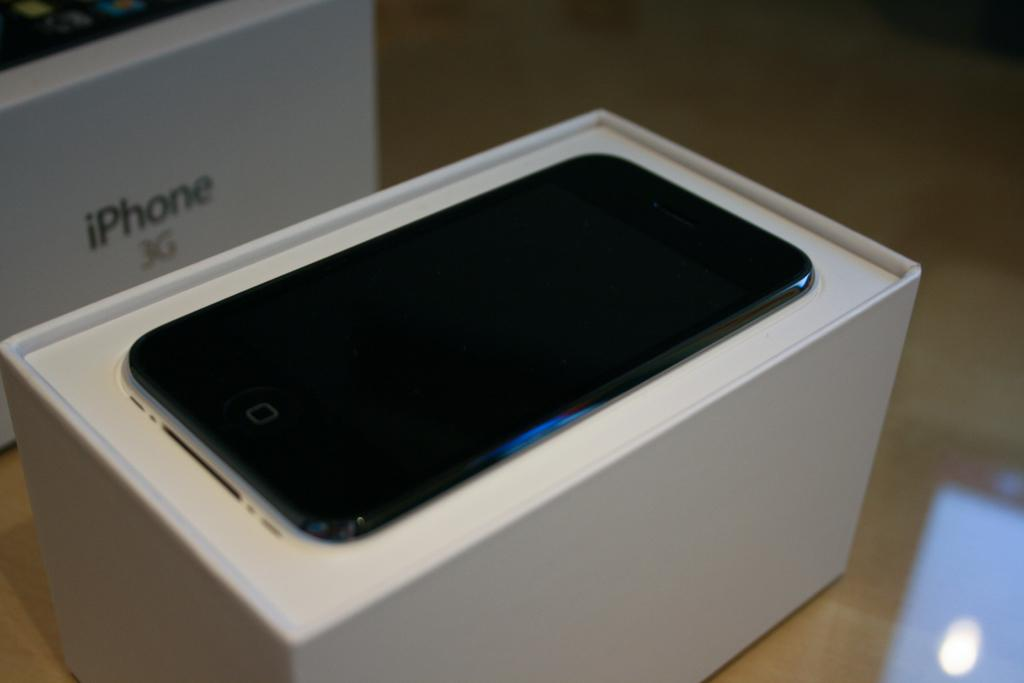<image>
Relay a brief, clear account of the picture shown. The Iphone 3G looks to be brand new in the box. 